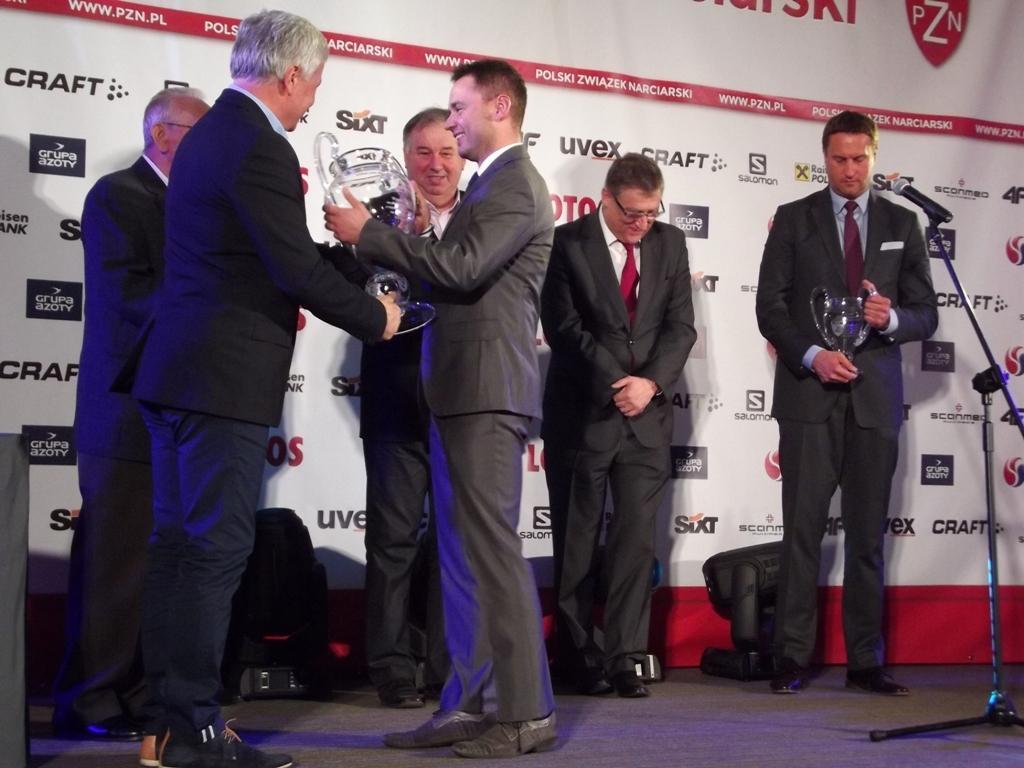How would you summarize this image in a sentence or two? In this image in the center there are persons standing and smiling. On the right side there is a mic and there is a board with some text written on it and there are objects on the floor which are black in colour and in the center there are persons standing and holding cup. 